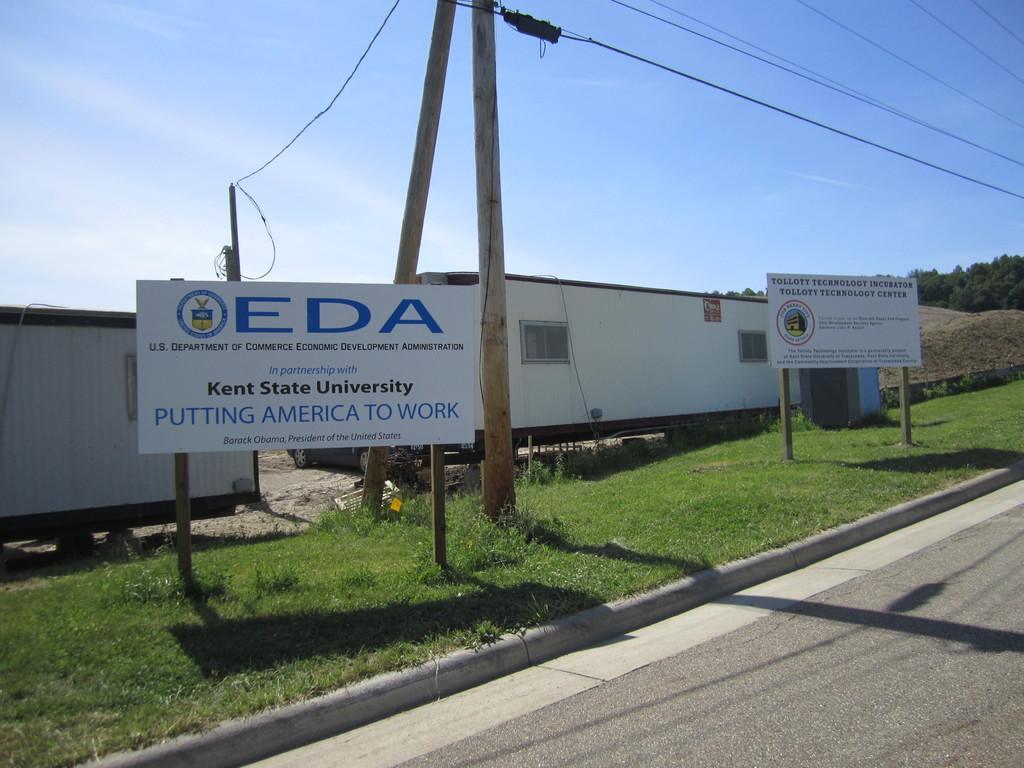Describe this image in one or two sentences. This image is clicked on the road. At the bottom, there is a road. Beside the road we can see green grass on the ground. In the front, there are two board. In the middle, there are electric poles. In the background, there are cabins. On the right, we can see a tree. At the top, there are wires and a sky. 